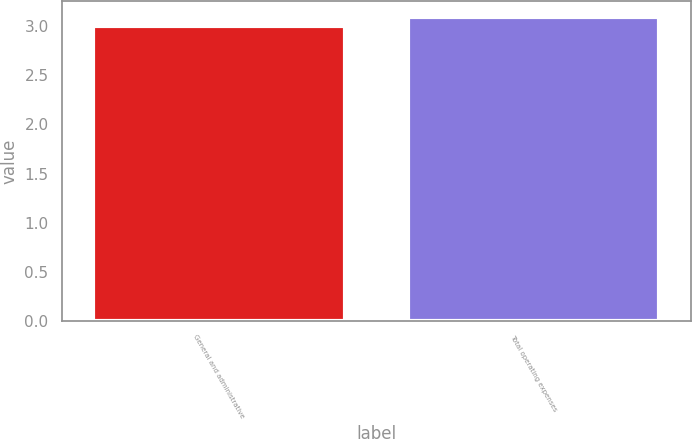Convert chart to OTSL. <chart><loc_0><loc_0><loc_500><loc_500><bar_chart><fcel>General and administrative<fcel>Total operating expenses<nl><fcel>3<fcel>3.1<nl></chart> 